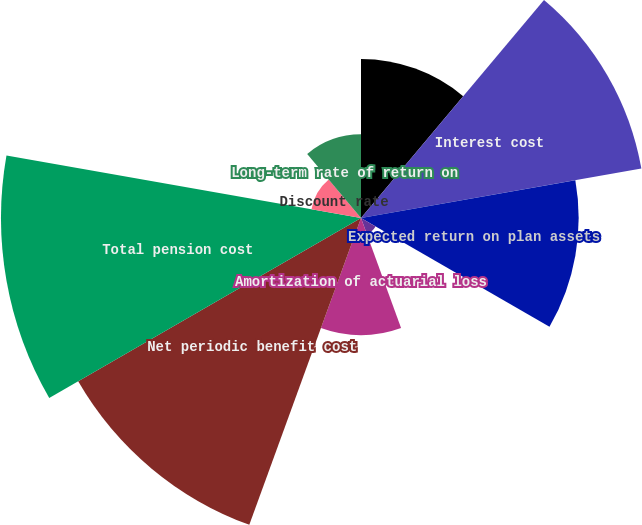Convert chart. <chart><loc_0><loc_0><loc_500><loc_500><pie_chart><fcel>Service cost<fcel>Interest cost<fcel>Expected return on plan assets<fcel>Amortization of transition &<fcel>Amortization of actuarial loss<fcel>Net periodic benefit cost<fcel>Total pension cost<fcel>Discount rate<fcel>Long-term rate of return on<nl><fcel>9.84%<fcel>17.62%<fcel>13.47%<fcel>1.04%<fcel>7.25%<fcel>20.21%<fcel>22.28%<fcel>3.11%<fcel>5.18%<nl></chart> 